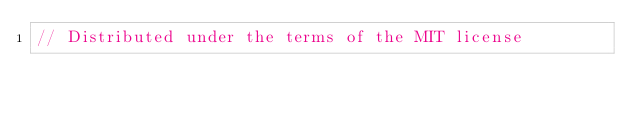Convert code to text. <code><loc_0><loc_0><loc_500><loc_500><_Swift_>// Distributed under the terms of the MIT license</code> 